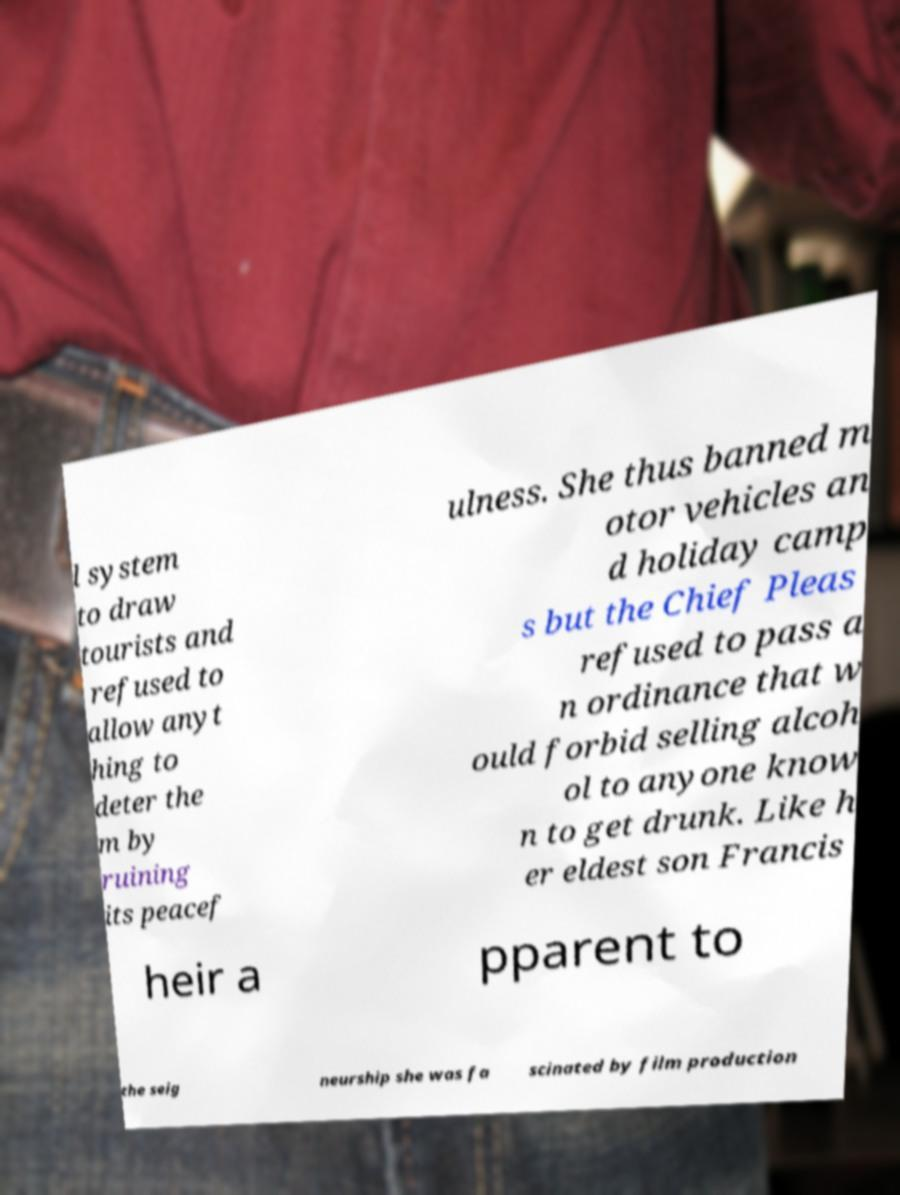Please read and relay the text visible in this image. What does it say? l system to draw tourists and refused to allow anyt hing to deter the m by ruining its peacef ulness. She thus banned m otor vehicles an d holiday camp s but the Chief Pleas refused to pass a n ordinance that w ould forbid selling alcoh ol to anyone know n to get drunk. Like h er eldest son Francis heir a pparent to the seig neurship she was fa scinated by film production 